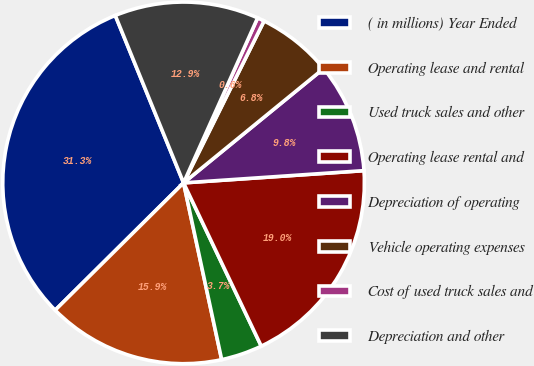Convert chart to OTSL. <chart><loc_0><loc_0><loc_500><loc_500><pie_chart><fcel>( in millions) Year Ended<fcel>Operating lease and rental<fcel>Used truck sales and other<fcel>Operating lease rental and<fcel>Depreciation of operating<fcel>Vehicle operating expenses<fcel>Cost of used truck sales and<fcel>Depreciation and other<nl><fcel>31.27%<fcel>15.95%<fcel>3.69%<fcel>19.01%<fcel>9.82%<fcel>6.76%<fcel>0.63%<fcel>12.88%<nl></chart> 